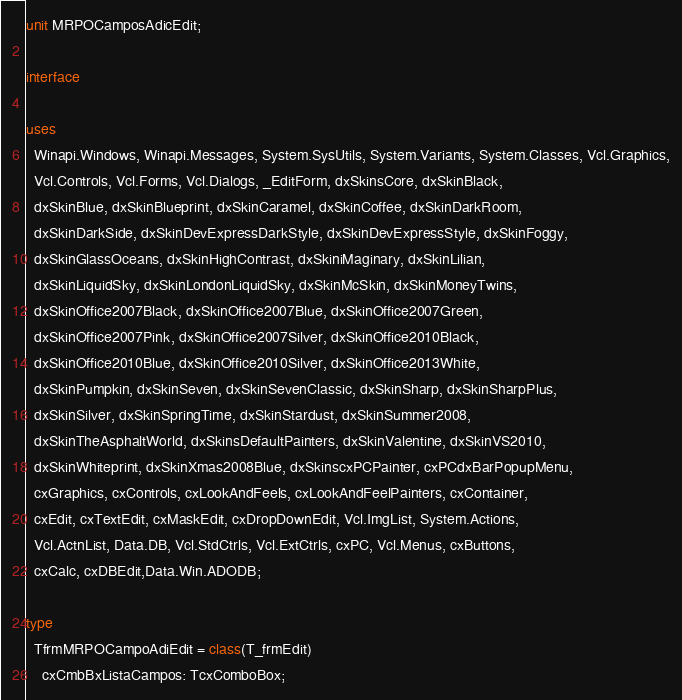Convert code to text. <code><loc_0><loc_0><loc_500><loc_500><_Pascal_>unit MRPOCamposAdicEdit;

interface

uses
  Winapi.Windows, Winapi.Messages, System.SysUtils, System.Variants, System.Classes, Vcl.Graphics,
  Vcl.Controls, Vcl.Forms, Vcl.Dialogs, _EditForm, dxSkinsCore, dxSkinBlack,
  dxSkinBlue, dxSkinBlueprint, dxSkinCaramel, dxSkinCoffee, dxSkinDarkRoom,
  dxSkinDarkSide, dxSkinDevExpressDarkStyle, dxSkinDevExpressStyle, dxSkinFoggy,
  dxSkinGlassOceans, dxSkinHighContrast, dxSkiniMaginary, dxSkinLilian,
  dxSkinLiquidSky, dxSkinLondonLiquidSky, dxSkinMcSkin, dxSkinMoneyTwins,
  dxSkinOffice2007Black, dxSkinOffice2007Blue, dxSkinOffice2007Green,
  dxSkinOffice2007Pink, dxSkinOffice2007Silver, dxSkinOffice2010Black,
  dxSkinOffice2010Blue, dxSkinOffice2010Silver, dxSkinOffice2013White,
  dxSkinPumpkin, dxSkinSeven, dxSkinSevenClassic, dxSkinSharp, dxSkinSharpPlus,
  dxSkinSilver, dxSkinSpringTime, dxSkinStardust, dxSkinSummer2008,
  dxSkinTheAsphaltWorld, dxSkinsDefaultPainters, dxSkinValentine, dxSkinVS2010,
  dxSkinWhiteprint, dxSkinXmas2008Blue, dxSkinscxPCPainter, cxPCdxBarPopupMenu,
  cxGraphics, cxControls, cxLookAndFeels, cxLookAndFeelPainters, cxContainer,
  cxEdit, cxTextEdit, cxMaskEdit, cxDropDownEdit, Vcl.ImgList, System.Actions,
  Vcl.ActnList, Data.DB, Vcl.StdCtrls, Vcl.ExtCtrls, cxPC, Vcl.Menus, cxButtons,
  cxCalc, cxDBEdit,Data.Win.ADODB;

type
  TfrmMRPOCampoAdiEdit = class(T_frmEdit)
    cxCmbBxListaCampos: TcxComboBox;</code> 